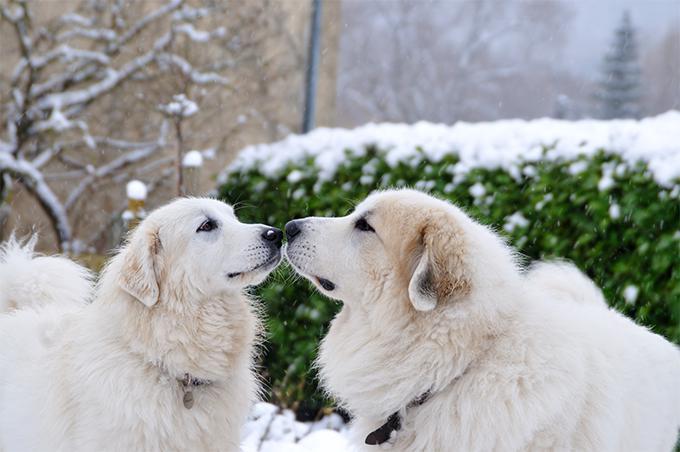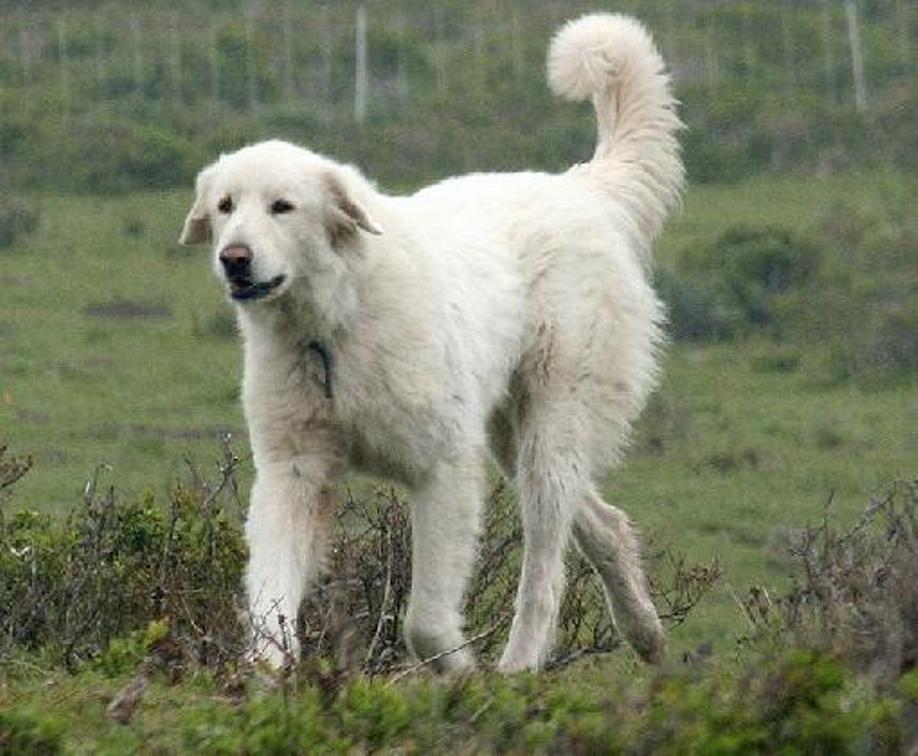The first image is the image on the left, the second image is the image on the right. For the images displayed, is the sentence "Exactly two large white dogs are standing upright." factually correct? Answer yes or no. No. The first image is the image on the left, the second image is the image on the right. Considering the images on both sides, is "There are only two dogs and both are standing with at least one of them on green grass." valid? Answer yes or no. No. 